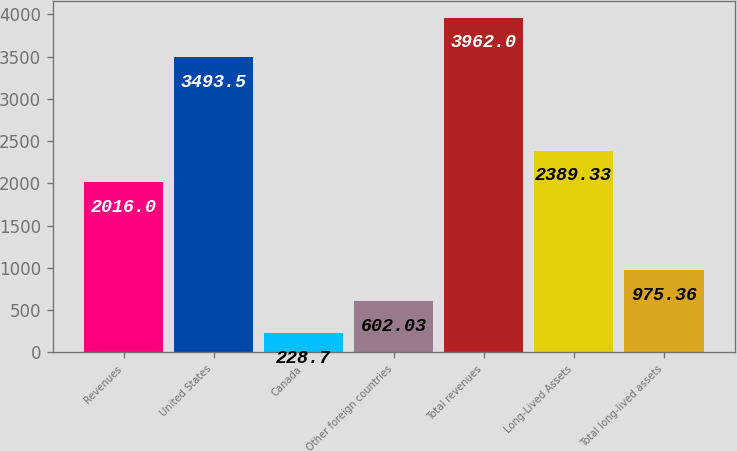Convert chart. <chart><loc_0><loc_0><loc_500><loc_500><bar_chart><fcel>Revenues<fcel>United States<fcel>Canada<fcel>Other foreign countries<fcel>Total revenues<fcel>Long-Lived Assets<fcel>Total long-lived assets<nl><fcel>2016<fcel>3493.5<fcel>228.7<fcel>602.03<fcel>3962<fcel>2389.33<fcel>975.36<nl></chart> 